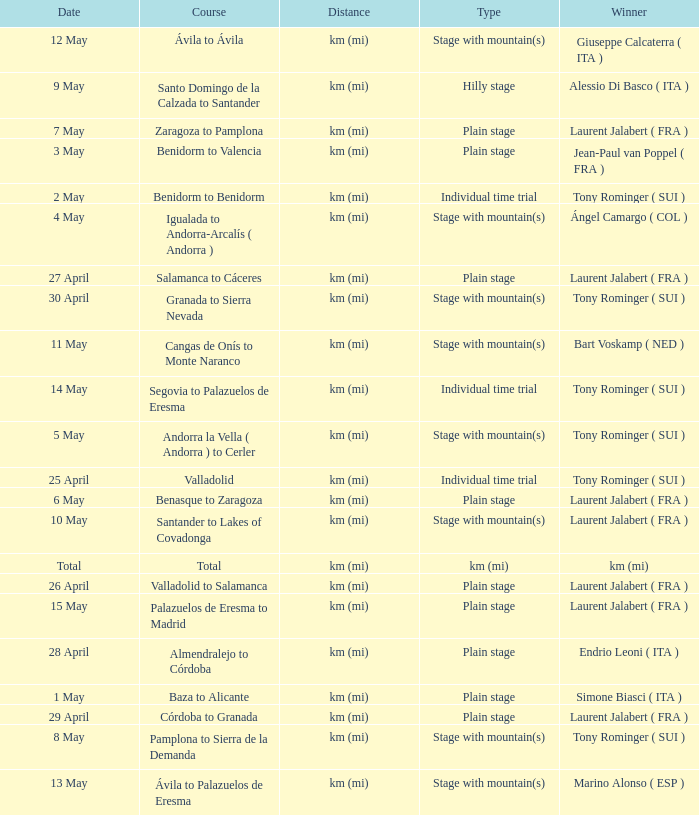What was the date with a winner of km (mi)? Total. 